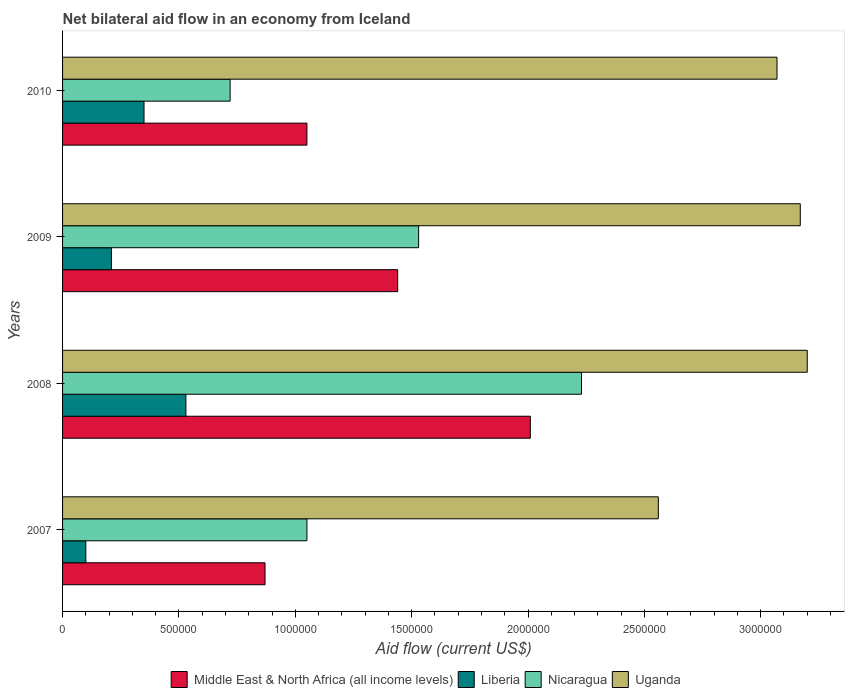Are the number of bars per tick equal to the number of legend labels?
Give a very brief answer. Yes. How many bars are there on the 2nd tick from the top?
Offer a very short reply. 4. What is the net bilateral aid flow in Liberia in 2008?
Your answer should be very brief. 5.30e+05. Across all years, what is the maximum net bilateral aid flow in Liberia?
Your response must be concise. 5.30e+05. Across all years, what is the minimum net bilateral aid flow in Nicaragua?
Give a very brief answer. 7.20e+05. In which year was the net bilateral aid flow in Uganda maximum?
Offer a very short reply. 2008. In which year was the net bilateral aid flow in Middle East & North Africa (all income levels) minimum?
Your answer should be very brief. 2007. What is the total net bilateral aid flow in Liberia in the graph?
Ensure brevity in your answer.  1.19e+06. What is the difference between the net bilateral aid flow in Nicaragua in 2007 and that in 2009?
Give a very brief answer. -4.80e+05. What is the difference between the net bilateral aid flow in Uganda in 2008 and the net bilateral aid flow in Nicaragua in 2007?
Keep it short and to the point. 2.15e+06. What is the average net bilateral aid flow in Middle East & North Africa (all income levels) per year?
Your answer should be compact. 1.34e+06. In the year 2008, what is the difference between the net bilateral aid flow in Nicaragua and net bilateral aid flow in Uganda?
Provide a succinct answer. -9.70e+05. What is the ratio of the net bilateral aid flow in Nicaragua in 2008 to that in 2010?
Offer a terse response. 3.1. Is the net bilateral aid flow in Uganda in 2007 less than that in 2010?
Provide a short and direct response. Yes. In how many years, is the net bilateral aid flow in Liberia greater than the average net bilateral aid flow in Liberia taken over all years?
Offer a very short reply. 2. Is the sum of the net bilateral aid flow in Liberia in 2009 and 2010 greater than the maximum net bilateral aid flow in Uganda across all years?
Keep it short and to the point. No. Is it the case that in every year, the sum of the net bilateral aid flow in Uganda and net bilateral aid flow in Liberia is greater than the sum of net bilateral aid flow in Middle East & North Africa (all income levels) and net bilateral aid flow in Nicaragua?
Offer a very short reply. No. What does the 4th bar from the top in 2009 represents?
Provide a succinct answer. Middle East & North Africa (all income levels). What does the 3rd bar from the bottom in 2007 represents?
Provide a succinct answer. Nicaragua. Is it the case that in every year, the sum of the net bilateral aid flow in Middle East & North Africa (all income levels) and net bilateral aid flow in Uganda is greater than the net bilateral aid flow in Liberia?
Ensure brevity in your answer.  Yes. What is the difference between two consecutive major ticks on the X-axis?
Your answer should be very brief. 5.00e+05. Are the values on the major ticks of X-axis written in scientific E-notation?
Give a very brief answer. No. Does the graph contain grids?
Give a very brief answer. No. What is the title of the graph?
Offer a terse response. Net bilateral aid flow in an economy from Iceland. Does "Europe(developing only)" appear as one of the legend labels in the graph?
Provide a short and direct response. No. What is the label or title of the X-axis?
Your answer should be compact. Aid flow (current US$). What is the Aid flow (current US$) in Middle East & North Africa (all income levels) in 2007?
Offer a very short reply. 8.70e+05. What is the Aid flow (current US$) of Nicaragua in 2007?
Provide a short and direct response. 1.05e+06. What is the Aid flow (current US$) of Uganda in 2007?
Keep it short and to the point. 2.56e+06. What is the Aid flow (current US$) of Middle East & North Africa (all income levels) in 2008?
Offer a very short reply. 2.01e+06. What is the Aid flow (current US$) of Liberia in 2008?
Your response must be concise. 5.30e+05. What is the Aid flow (current US$) in Nicaragua in 2008?
Make the answer very short. 2.23e+06. What is the Aid flow (current US$) in Uganda in 2008?
Offer a very short reply. 3.20e+06. What is the Aid flow (current US$) in Middle East & North Africa (all income levels) in 2009?
Your answer should be compact. 1.44e+06. What is the Aid flow (current US$) in Nicaragua in 2009?
Offer a terse response. 1.53e+06. What is the Aid flow (current US$) of Uganda in 2009?
Provide a succinct answer. 3.17e+06. What is the Aid flow (current US$) in Middle East & North Africa (all income levels) in 2010?
Your response must be concise. 1.05e+06. What is the Aid flow (current US$) in Liberia in 2010?
Your response must be concise. 3.50e+05. What is the Aid flow (current US$) in Nicaragua in 2010?
Make the answer very short. 7.20e+05. What is the Aid flow (current US$) in Uganda in 2010?
Your answer should be compact. 3.07e+06. Across all years, what is the maximum Aid flow (current US$) in Middle East & North Africa (all income levels)?
Your answer should be very brief. 2.01e+06. Across all years, what is the maximum Aid flow (current US$) in Liberia?
Ensure brevity in your answer.  5.30e+05. Across all years, what is the maximum Aid flow (current US$) in Nicaragua?
Provide a short and direct response. 2.23e+06. Across all years, what is the maximum Aid flow (current US$) in Uganda?
Your response must be concise. 3.20e+06. Across all years, what is the minimum Aid flow (current US$) of Middle East & North Africa (all income levels)?
Offer a terse response. 8.70e+05. Across all years, what is the minimum Aid flow (current US$) in Nicaragua?
Give a very brief answer. 7.20e+05. Across all years, what is the minimum Aid flow (current US$) in Uganda?
Keep it short and to the point. 2.56e+06. What is the total Aid flow (current US$) of Middle East & North Africa (all income levels) in the graph?
Your answer should be compact. 5.37e+06. What is the total Aid flow (current US$) in Liberia in the graph?
Provide a succinct answer. 1.19e+06. What is the total Aid flow (current US$) of Nicaragua in the graph?
Your answer should be very brief. 5.53e+06. What is the total Aid flow (current US$) of Uganda in the graph?
Offer a very short reply. 1.20e+07. What is the difference between the Aid flow (current US$) in Middle East & North Africa (all income levels) in 2007 and that in 2008?
Your answer should be compact. -1.14e+06. What is the difference between the Aid flow (current US$) in Liberia in 2007 and that in 2008?
Keep it short and to the point. -4.30e+05. What is the difference between the Aid flow (current US$) in Nicaragua in 2007 and that in 2008?
Provide a succinct answer. -1.18e+06. What is the difference between the Aid flow (current US$) in Uganda in 2007 and that in 2008?
Your answer should be very brief. -6.40e+05. What is the difference between the Aid flow (current US$) in Middle East & North Africa (all income levels) in 2007 and that in 2009?
Provide a succinct answer. -5.70e+05. What is the difference between the Aid flow (current US$) of Liberia in 2007 and that in 2009?
Offer a terse response. -1.10e+05. What is the difference between the Aid flow (current US$) in Nicaragua in 2007 and that in 2009?
Make the answer very short. -4.80e+05. What is the difference between the Aid flow (current US$) in Uganda in 2007 and that in 2009?
Make the answer very short. -6.10e+05. What is the difference between the Aid flow (current US$) in Middle East & North Africa (all income levels) in 2007 and that in 2010?
Ensure brevity in your answer.  -1.80e+05. What is the difference between the Aid flow (current US$) in Nicaragua in 2007 and that in 2010?
Give a very brief answer. 3.30e+05. What is the difference between the Aid flow (current US$) in Uganda in 2007 and that in 2010?
Provide a succinct answer. -5.10e+05. What is the difference between the Aid flow (current US$) of Middle East & North Africa (all income levels) in 2008 and that in 2009?
Offer a very short reply. 5.70e+05. What is the difference between the Aid flow (current US$) in Nicaragua in 2008 and that in 2009?
Your answer should be compact. 7.00e+05. What is the difference between the Aid flow (current US$) in Uganda in 2008 and that in 2009?
Ensure brevity in your answer.  3.00e+04. What is the difference between the Aid flow (current US$) in Middle East & North Africa (all income levels) in 2008 and that in 2010?
Make the answer very short. 9.60e+05. What is the difference between the Aid flow (current US$) in Nicaragua in 2008 and that in 2010?
Provide a succinct answer. 1.51e+06. What is the difference between the Aid flow (current US$) in Uganda in 2008 and that in 2010?
Offer a very short reply. 1.30e+05. What is the difference between the Aid flow (current US$) of Liberia in 2009 and that in 2010?
Offer a terse response. -1.40e+05. What is the difference between the Aid flow (current US$) of Nicaragua in 2009 and that in 2010?
Keep it short and to the point. 8.10e+05. What is the difference between the Aid flow (current US$) of Uganda in 2009 and that in 2010?
Ensure brevity in your answer.  1.00e+05. What is the difference between the Aid flow (current US$) in Middle East & North Africa (all income levels) in 2007 and the Aid flow (current US$) in Nicaragua in 2008?
Provide a succinct answer. -1.36e+06. What is the difference between the Aid flow (current US$) in Middle East & North Africa (all income levels) in 2007 and the Aid flow (current US$) in Uganda in 2008?
Your answer should be very brief. -2.33e+06. What is the difference between the Aid flow (current US$) in Liberia in 2007 and the Aid flow (current US$) in Nicaragua in 2008?
Offer a terse response. -2.13e+06. What is the difference between the Aid flow (current US$) in Liberia in 2007 and the Aid flow (current US$) in Uganda in 2008?
Your answer should be compact. -3.10e+06. What is the difference between the Aid flow (current US$) in Nicaragua in 2007 and the Aid flow (current US$) in Uganda in 2008?
Your response must be concise. -2.15e+06. What is the difference between the Aid flow (current US$) of Middle East & North Africa (all income levels) in 2007 and the Aid flow (current US$) of Liberia in 2009?
Give a very brief answer. 6.60e+05. What is the difference between the Aid flow (current US$) of Middle East & North Africa (all income levels) in 2007 and the Aid flow (current US$) of Nicaragua in 2009?
Give a very brief answer. -6.60e+05. What is the difference between the Aid flow (current US$) in Middle East & North Africa (all income levels) in 2007 and the Aid flow (current US$) in Uganda in 2009?
Provide a short and direct response. -2.30e+06. What is the difference between the Aid flow (current US$) of Liberia in 2007 and the Aid flow (current US$) of Nicaragua in 2009?
Provide a succinct answer. -1.43e+06. What is the difference between the Aid flow (current US$) in Liberia in 2007 and the Aid flow (current US$) in Uganda in 2009?
Make the answer very short. -3.07e+06. What is the difference between the Aid flow (current US$) in Nicaragua in 2007 and the Aid flow (current US$) in Uganda in 2009?
Your answer should be compact. -2.12e+06. What is the difference between the Aid flow (current US$) in Middle East & North Africa (all income levels) in 2007 and the Aid flow (current US$) in Liberia in 2010?
Provide a short and direct response. 5.20e+05. What is the difference between the Aid flow (current US$) in Middle East & North Africa (all income levels) in 2007 and the Aid flow (current US$) in Uganda in 2010?
Give a very brief answer. -2.20e+06. What is the difference between the Aid flow (current US$) in Liberia in 2007 and the Aid flow (current US$) in Nicaragua in 2010?
Provide a succinct answer. -6.20e+05. What is the difference between the Aid flow (current US$) in Liberia in 2007 and the Aid flow (current US$) in Uganda in 2010?
Your answer should be very brief. -2.97e+06. What is the difference between the Aid flow (current US$) of Nicaragua in 2007 and the Aid flow (current US$) of Uganda in 2010?
Give a very brief answer. -2.02e+06. What is the difference between the Aid flow (current US$) of Middle East & North Africa (all income levels) in 2008 and the Aid flow (current US$) of Liberia in 2009?
Offer a very short reply. 1.80e+06. What is the difference between the Aid flow (current US$) of Middle East & North Africa (all income levels) in 2008 and the Aid flow (current US$) of Nicaragua in 2009?
Provide a succinct answer. 4.80e+05. What is the difference between the Aid flow (current US$) of Middle East & North Africa (all income levels) in 2008 and the Aid flow (current US$) of Uganda in 2009?
Ensure brevity in your answer.  -1.16e+06. What is the difference between the Aid flow (current US$) in Liberia in 2008 and the Aid flow (current US$) in Uganda in 2009?
Make the answer very short. -2.64e+06. What is the difference between the Aid flow (current US$) of Nicaragua in 2008 and the Aid flow (current US$) of Uganda in 2009?
Offer a terse response. -9.40e+05. What is the difference between the Aid flow (current US$) of Middle East & North Africa (all income levels) in 2008 and the Aid flow (current US$) of Liberia in 2010?
Ensure brevity in your answer.  1.66e+06. What is the difference between the Aid flow (current US$) in Middle East & North Africa (all income levels) in 2008 and the Aid flow (current US$) in Nicaragua in 2010?
Offer a very short reply. 1.29e+06. What is the difference between the Aid flow (current US$) of Middle East & North Africa (all income levels) in 2008 and the Aid flow (current US$) of Uganda in 2010?
Ensure brevity in your answer.  -1.06e+06. What is the difference between the Aid flow (current US$) of Liberia in 2008 and the Aid flow (current US$) of Uganda in 2010?
Give a very brief answer. -2.54e+06. What is the difference between the Aid flow (current US$) in Nicaragua in 2008 and the Aid flow (current US$) in Uganda in 2010?
Provide a succinct answer. -8.40e+05. What is the difference between the Aid flow (current US$) in Middle East & North Africa (all income levels) in 2009 and the Aid flow (current US$) in Liberia in 2010?
Make the answer very short. 1.09e+06. What is the difference between the Aid flow (current US$) in Middle East & North Africa (all income levels) in 2009 and the Aid flow (current US$) in Nicaragua in 2010?
Offer a very short reply. 7.20e+05. What is the difference between the Aid flow (current US$) of Middle East & North Africa (all income levels) in 2009 and the Aid flow (current US$) of Uganda in 2010?
Your answer should be compact. -1.63e+06. What is the difference between the Aid flow (current US$) of Liberia in 2009 and the Aid flow (current US$) of Nicaragua in 2010?
Your response must be concise. -5.10e+05. What is the difference between the Aid flow (current US$) of Liberia in 2009 and the Aid flow (current US$) of Uganda in 2010?
Make the answer very short. -2.86e+06. What is the difference between the Aid flow (current US$) of Nicaragua in 2009 and the Aid flow (current US$) of Uganda in 2010?
Your answer should be compact. -1.54e+06. What is the average Aid flow (current US$) in Middle East & North Africa (all income levels) per year?
Ensure brevity in your answer.  1.34e+06. What is the average Aid flow (current US$) of Liberia per year?
Give a very brief answer. 2.98e+05. What is the average Aid flow (current US$) in Nicaragua per year?
Provide a short and direct response. 1.38e+06. What is the average Aid flow (current US$) of Uganda per year?
Provide a succinct answer. 3.00e+06. In the year 2007, what is the difference between the Aid flow (current US$) in Middle East & North Africa (all income levels) and Aid flow (current US$) in Liberia?
Your answer should be compact. 7.70e+05. In the year 2007, what is the difference between the Aid flow (current US$) in Middle East & North Africa (all income levels) and Aid flow (current US$) in Uganda?
Give a very brief answer. -1.69e+06. In the year 2007, what is the difference between the Aid flow (current US$) in Liberia and Aid flow (current US$) in Nicaragua?
Your answer should be compact. -9.50e+05. In the year 2007, what is the difference between the Aid flow (current US$) of Liberia and Aid flow (current US$) of Uganda?
Make the answer very short. -2.46e+06. In the year 2007, what is the difference between the Aid flow (current US$) in Nicaragua and Aid flow (current US$) in Uganda?
Offer a very short reply. -1.51e+06. In the year 2008, what is the difference between the Aid flow (current US$) in Middle East & North Africa (all income levels) and Aid flow (current US$) in Liberia?
Provide a short and direct response. 1.48e+06. In the year 2008, what is the difference between the Aid flow (current US$) of Middle East & North Africa (all income levels) and Aid flow (current US$) of Uganda?
Provide a short and direct response. -1.19e+06. In the year 2008, what is the difference between the Aid flow (current US$) in Liberia and Aid flow (current US$) in Nicaragua?
Offer a terse response. -1.70e+06. In the year 2008, what is the difference between the Aid flow (current US$) in Liberia and Aid flow (current US$) in Uganda?
Keep it short and to the point. -2.67e+06. In the year 2008, what is the difference between the Aid flow (current US$) of Nicaragua and Aid flow (current US$) of Uganda?
Make the answer very short. -9.70e+05. In the year 2009, what is the difference between the Aid flow (current US$) of Middle East & North Africa (all income levels) and Aid flow (current US$) of Liberia?
Your response must be concise. 1.23e+06. In the year 2009, what is the difference between the Aid flow (current US$) in Middle East & North Africa (all income levels) and Aid flow (current US$) in Uganda?
Your answer should be very brief. -1.73e+06. In the year 2009, what is the difference between the Aid flow (current US$) of Liberia and Aid flow (current US$) of Nicaragua?
Your answer should be very brief. -1.32e+06. In the year 2009, what is the difference between the Aid flow (current US$) of Liberia and Aid flow (current US$) of Uganda?
Your answer should be very brief. -2.96e+06. In the year 2009, what is the difference between the Aid flow (current US$) in Nicaragua and Aid flow (current US$) in Uganda?
Your answer should be compact. -1.64e+06. In the year 2010, what is the difference between the Aid flow (current US$) of Middle East & North Africa (all income levels) and Aid flow (current US$) of Liberia?
Provide a succinct answer. 7.00e+05. In the year 2010, what is the difference between the Aid flow (current US$) of Middle East & North Africa (all income levels) and Aid flow (current US$) of Nicaragua?
Your answer should be very brief. 3.30e+05. In the year 2010, what is the difference between the Aid flow (current US$) in Middle East & North Africa (all income levels) and Aid flow (current US$) in Uganda?
Keep it short and to the point. -2.02e+06. In the year 2010, what is the difference between the Aid flow (current US$) in Liberia and Aid flow (current US$) in Nicaragua?
Ensure brevity in your answer.  -3.70e+05. In the year 2010, what is the difference between the Aid flow (current US$) of Liberia and Aid flow (current US$) of Uganda?
Ensure brevity in your answer.  -2.72e+06. In the year 2010, what is the difference between the Aid flow (current US$) in Nicaragua and Aid flow (current US$) in Uganda?
Your response must be concise. -2.35e+06. What is the ratio of the Aid flow (current US$) in Middle East & North Africa (all income levels) in 2007 to that in 2008?
Offer a very short reply. 0.43. What is the ratio of the Aid flow (current US$) in Liberia in 2007 to that in 2008?
Provide a succinct answer. 0.19. What is the ratio of the Aid flow (current US$) of Nicaragua in 2007 to that in 2008?
Give a very brief answer. 0.47. What is the ratio of the Aid flow (current US$) in Middle East & North Africa (all income levels) in 2007 to that in 2009?
Your answer should be compact. 0.6. What is the ratio of the Aid flow (current US$) of Liberia in 2007 to that in 2009?
Keep it short and to the point. 0.48. What is the ratio of the Aid flow (current US$) of Nicaragua in 2007 to that in 2009?
Your answer should be very brief. 0.69. What is the ratio of the Aid flow (current US$) in Uganda in 2007 to that in 2009?
Offer a very short reply. 0.81. What is the ratio of the Aid flow (current US$) in Middle East & North Africa (all income levels) in 2007 to that in 2010?
Your response must be concise. 0.83. What is the ratio of the Aid flow (current US$) of Liberia in 2007 to that in 2010?
Provide a succinct answer. 0.29. What is the ratio of the Aid flow (current US$) in Nicaragua in 2007 to that in 2010?
Offer a terse response. 1.46. What is the ratio of the Aid flow (current US$) of Uganda in 2007 to that in 2010?
Offer a terse response. 0.83. What is the ratio of the Aid flow (current US$) in Middle East & North Africa (all income levels) in 2008 to that in 2009?
Ensure brevity in your answer.  1.4. What is the ratio of the Aid flow (current US$) in Liberia in 2008 to that in 2009?
Provide a succinct answer. 2.52. What is the ratio of the Aid flow (current US$) of Nicaragua in 2008 to that in 2009?
Keep it short and to the point. 1.46. What is the ratio of the Aid flow (current US$) of Uganda in 2008 to that in 2009?
Offer a very short reply. 1.01. What is the ratio of the Aid flow (current US$) in Middle East & North Africa (all income levels) in 2008 to that in 2010?
Your answer should be very brief. 1.91. What is the ratio of the Aid flow (current US$) in Liberia in 2008 to that in 2010?
Offer a terse response. 1.51. What is the ratio of the Aid flow (current US$) in Nicaragua in 2008 to that in 2010?
Offer a very short reply. 3.1. What is the ratio of the Aid flow (current US$) of Uganda in 2008 to that in 2010?
Offer a terse response. 1.04. What is the ratio of the Aid flow (current US$) of Middle East & North Africa (all income levels) in 2009 to that in 2010?
Provide a succinct answer. 1.37. What is the ratio of the Aid flow (current US$) in Liberia in 2009 to that in 2010?
Your answer should be very brief. 0.6. What is the ratio of the Aid flow (current US$) of Nicaragua in 2009 to that in 2010?
Ensure brevity in your answer.  2.12. What is the ratio of the Aid flow (current US$) of Uganda in 2009 to that in 2010?
Offer a terse response. 1.03. What is the difference between the highest and the second highest Aid flow (current US$) in Middle East & North Africa (all income levels)?
Your answer should be very brief. 5.70e+05. What is the difference between the highest and the second highest Aid flow (current US$) of Nicaragua?
Your answer should be very brief. 7.00e+05. What is the difference between the highest and the lowest Aid flow (current US$) in Middle East & North Africa (all income levels)?
Your response must be concise. 1.14e+06. What is the difference between the highest and the lowest Aid flow (current US$) of Liberia?
Your answer should be compact. 4.30e+05. What is the difference between the highest and the lowest Aid flow (current US$) in Nicaragua?
Provide a short and direct response. 1.51e+06. What is the difference between the highest and the lowest Aid flow (current US$) in Uganda?
Your response must be concise. 6.40e+05. 